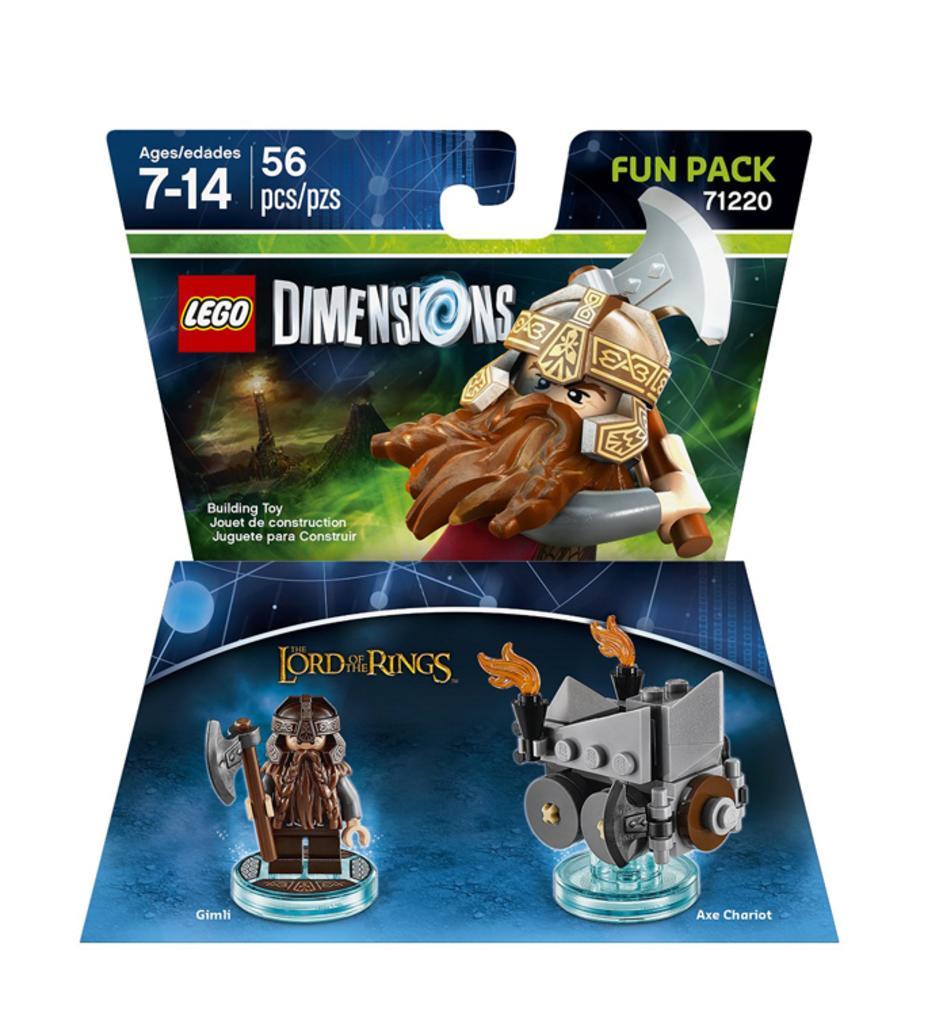Can you describe this image briefly? In this picture we can see two posters, here we can see animated images and some text and in the background we can see it is white color. 